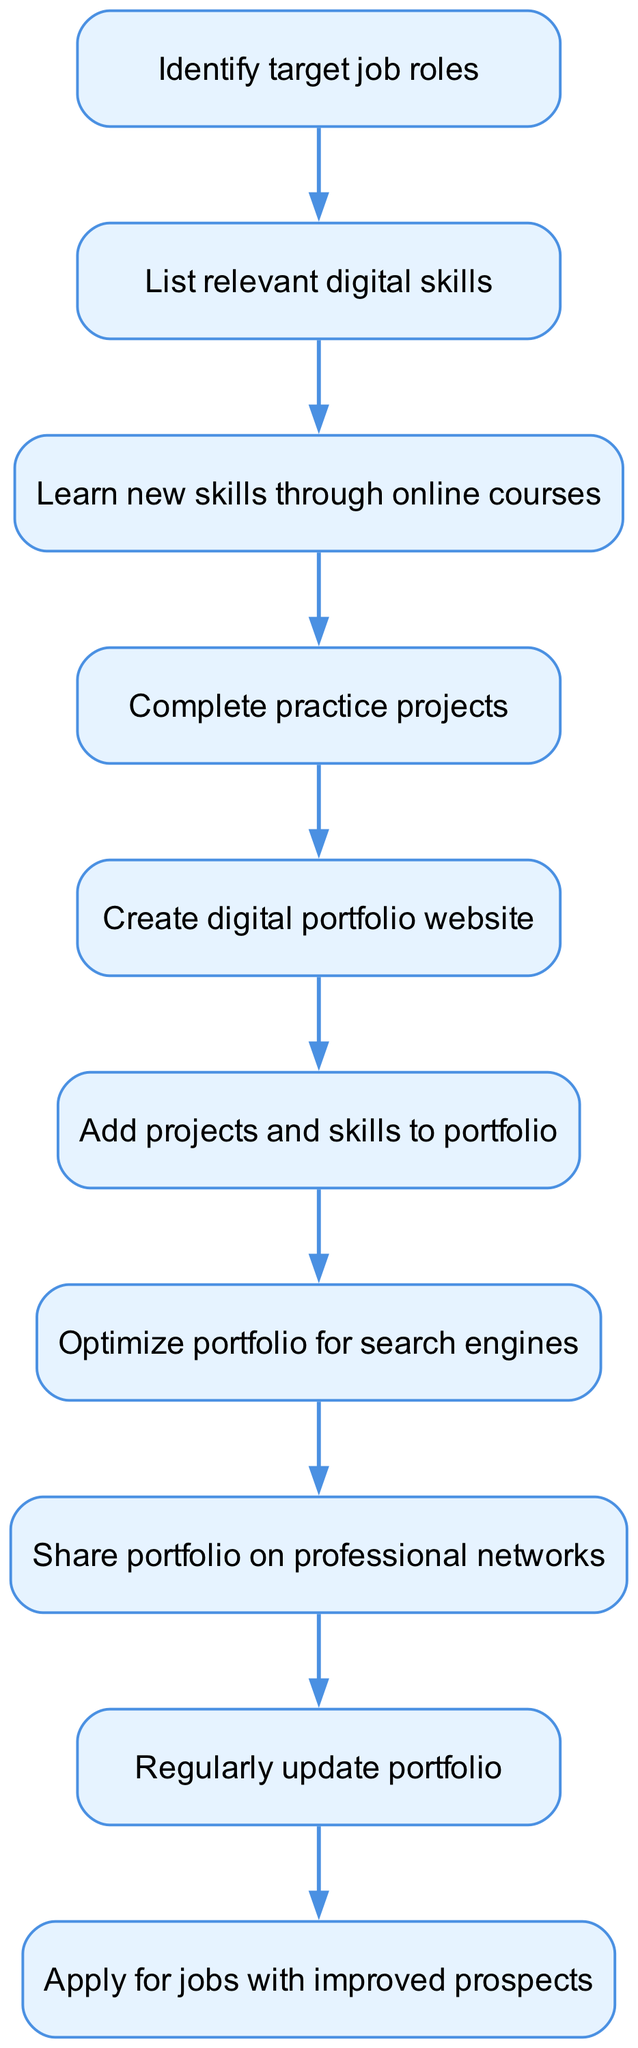What is the first step in creating a digital portfolio? The first node in the flowchart indicates that the starting point is to identify the target job roles.
Answer: Identify target job roles How many nodes are there in this flowchart? Counting all the distinct steps included in the diagram, there are ten nodes present.
Answer: Ten What is the last step in the process? The final node shows that after regularly updating the portfolio, the last action is to apply for jobs with improved prospects.
Answer: Apply for jobs with improved prospects Which step comes after listing relevant digital skills? The flowchart shows a direct progression; after listing relevant digital skills, the next step is to learn new skills through online courses.
Answer: Learn new skills through online courses In which step do you optimize the portfolio? The diagram reveals that after showcasing projects and skills, the step to optimize the portfolio for search engines follows.
Answer: Optimize portfolio for search engines How many edges connect the nodes in this flowchart? By observing the connections between nodes in the diagram, there are nine edges that represent the pathways between the various steps in the process.
Answer: Nine What action follows sharing the portfolio on professional networks? The flowchart indicates that after sharing the portfolio, the next step is to regularly update the portfolio.
Answer: Regularly update portfolio What is the relationship between the nodes "create" and "showcase"? The flowchart shows a direct relationship where creating the digital portfolio website precedes the action of adding projects and skills to the portfolio.
Answer: Create digital portfolio website → Add projects and skills to portfolio 